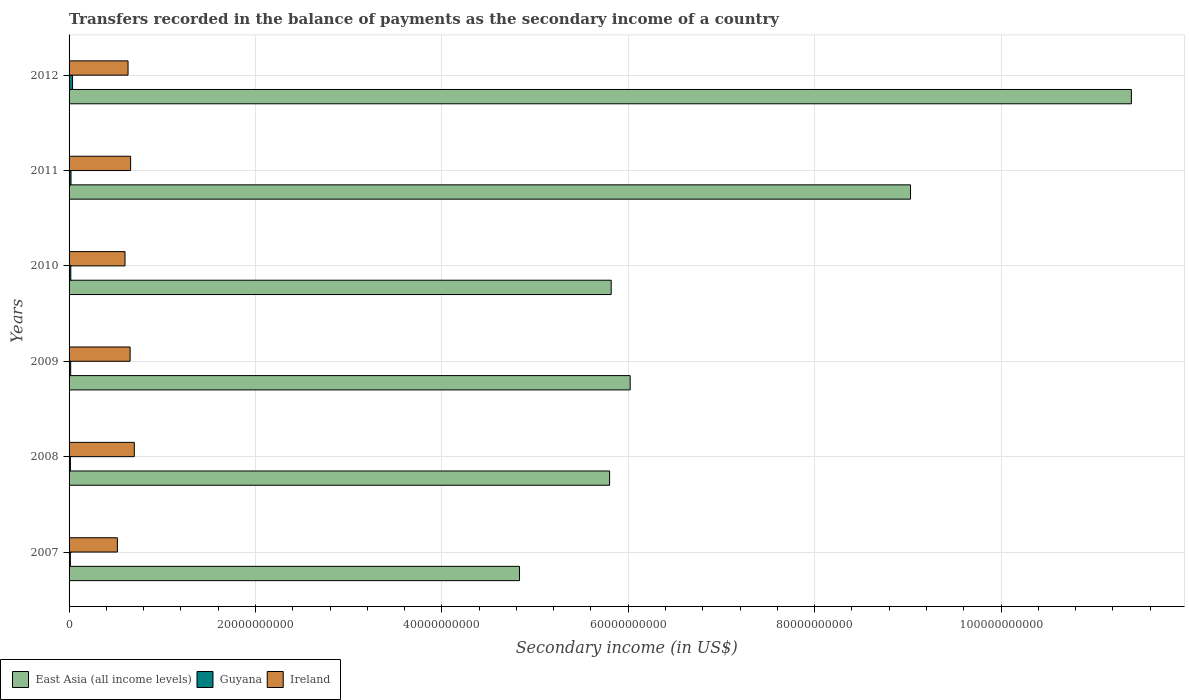Are the number of bars on each tick of the Y-axis equal?
Offer a terse response. Yes. How many bars are there on the 5th tick from the top?
Keep it short and to the point. 3. How many bars are there on the 1st tick from the bottom?
Provide a succinct answer. 3. What is the secondary income of in Ireland in 2010?
Give a very brief answer. 6.00e+09. Across all years, what is the maximum secondary income of in Ireland?
Make the answer very short. 7.00e+09. Across all years, what is the minimum secondary income of in Ireland?
Offer a terse response. 5.18e+09. What is the total secondary income of in East Asia (all income levels) in the graph?
Give a very brief answer. 4.29e+11. What is the difference between the secondary income of in East Asia (all income levels) in 2010 and that in 2011?
Your response must be concise. -3.21e+1. What is the difference between the secondary income of in Guyana in 2010 and the secondary income of in Ireland in 2012?
Keep it short and to the point. -6.14e+09. What is the average secondary income of in East Asia (all income levels) per year?
Offer a terse response. 7.15e+1. In the year 2007, what is the difference between the secondary income of in Ireland and secondary income of in East Asia (all income levels)?
Give a very brief answer. -4.31e+1. What is the ratio of the secondary income of in Ireland in 2007 to that in 2012?
Ensure brevity in your answer.  0.82. Is the difference between the secondary income of in Ireland in 2007 and 2012 greater than the difference between the secondary income of in East Asia (all income levels) in 2007 and 2012?
Keep it short and to the point. Yes. What is the difference between the highest and the second highest secondary income of in Ireland?
Provide a short and direct response. 3.96e+08. What is the difference between the highest and the lowest secondary income of in Ireland?
Make the answer very short. 1.82e+09. In how many years, is the secondary income of in Guyana greater than the average secondary income of in Guyana taken over all years?
Make the answer very short. 2. What does the 3rd bar from the top in 2007 represents?
Your answer should be very brief. East Asia (all income levels). What does the 3rd bar from the bottom in 2010 represents?
Ensure brevity in your answer.  Ireland. Is it the case that in every year, the sum of the secondary income of in Ireland and secondary income of in East Asia (all income levels) is greater than the secondary income of in Guyana?
Keep it short and to the point. Yes. How many bars are there?
Provide a succinct answer. 18. Are the values on the major ticks of X-axis written in scientific E-notation?
Provide a short and direct response. No. Does the graph contain any zero values?
Your response must be concise. No. Does the graph contain grids?
Your answer should be compact. Yes. Where does the legend appear in the graph?
Ensure brevity in your answer.  Bottom left. How are the legend labels stacked?
Provide a short and direct response. Horizontal. What is the title of the graph?
Offer a very short reply. Transfers recorded in the balance of payments as the secondary income of a country. What is the label or title of the X-axis?
Make the answer very short. Secondary income (in US$). What is the Secondary income (in US$) of East Asia (all income levels) in 2007?
Provide a short and direct response. 4.83e+1. What is the Secondary income (in US$) of Guyana in 2007?
Your answer should be compact. 1.37e+08. What is the Secondary income (in US$) of Ireland in 2007?
Provide a short and direct response. 5.18e+09. What is the Secondary income (in US$) in East Asia (all income levels) in 2008?
Make the answer very short. 5.80e+1. What is the Secondary income (in US$) in Guyana in 2008?
Your answer should be very brief. 1.41e+08. What is the Secondary income (in US$) in Ireland in 2008?
Give a very brief answer. 7.00e+09. What is the Secondary income (in US$) of East Asia (all income levels) in 2009?
Make the answer very short. 6.02e+1. What is the Secondary income (in US$) of Guyana in 2009?
Make the answer very short. 1.72e+08. What is the Secondary income (in US$) in Ireland in 2009?
Provide a short and direct response. 6.55e+09. What is the Secondary income (in US$) of East Asia (all income levels) in 2010?
Your response must be concise. 5.82e+1. What is the Secondary income (in US$) of Guyana in 2010?
Provide a succinct answer. 1.85e+08. What is the Secondary income (in US$) in Ireland in 2010?
Offer a very short reply. 6.00e+09. What is the Secondary income (in US$) in East Asia (all income levels) in 2011?
Make the answer very short. 9.03e+1. What is the Secondary income (in US$) in Guyana in 2011?
Ensure brevity in your answer.  2.08e+08. What is the Secondary income (in US$) of Ireland in 2011?
Keep it short and to the point. 6.61e+09. What is the Secondary income (in US$) of East Asia (all income levels) in 2012?
Provide a short and direct response. 1.14e+11. What is the Secondary income (in US$) in Guyana in 2012?
Ensure brevity in your answer.  3.71e+08. What is the Secondary income (in US$) of Ireland in 2012?
Make the answer very short. 6.33e+09. Across all years, what is the maximum Secondary income (in US$) of East Asia (all income levels)?
Keep it short and to the point. 1.14e+11. Across all years, what is the maximum Secondary income (in US$) of Guyana?
Your response must be concise. 3.71e+08. Across all years, what is the maximum Secondary income (in US$) in Ireland?
Ensure brevity in your answer.  7.00e+09. Across all years, what is the minimum Secondary income (in US$) in East Asia (all income levels)?
Give a very brief answer. 4.83e+1. Across all years, what is the minimum Secondary income (in US$) in Guyana?
Give a very brief answer. 1.37e+08. Across all years, what is the minimum Secondary income (in US$) of Ireland?
Give a very brief answer. 5.18e+09. What is the total Secondary income (in US$) in East Asia (all income levels) in the graph?
Make the answer very short. 4.29e+11. What is the total Secondary income (in US$) of Guyana in the graph?
Your answer should be compact. 1.21e+09. What is the total Secondary income (in US$) in Ireland in the graph?
Your answer should be very brief. 3.77e+1. What is the difference between the Secondary income (in US$) of East Asia (all income levels) in 2007 and that in 2008?
Keep it short and to the point. -9.67e+09. What is the difference between the Secondary income (in US$) in Guyana in 2007 and that in 2008?
Provide a succinct answer. -4.12e+06. What is the difference between the Secondary income (in US$) in Ireland in 2007 and that in 2008?
Offer a very short reply. -1.82e+09. What is the difference between the Secondary income (in US$) of East Asia (all income levels) in 2007 and that in 2009?
Provide a succinct answer. -1.19e+1. What is the difference between the Secondary income (in US$) of Guyana in 2007 and that in 2009?
Keep it short and to the point. -3.51e+07. What is the difference between the Secondary income (in US$) in Ireland in 2007 and that in 2009?
Your response must be concise. -1.37e+09. What is the difference between the Secondary income (in US$) of East Asia (all income levels) in 2007 and that in 2010?
Give a very brief answer. -9.84e+09. What is the difference between the Secondary income (in US$) of Guyana in 2007 and that in 2010?
Offer a very short reply. -4.78e+07. What is the difference between the Secondary income (in US$) of Ireland in 2007 and that in 2010?
Ensure brevity in your answer.  -8.19e+08. What is the difference between the Secondary income (in US$) in East Asia (all income levels) in 2007 and that in 2011?
Your answer should be very brief. -4.20e+1. What is the difference between the Secondary income (in US$) of Guyana in 2007 and that in 2011?
Your response must be concise. -7.14e+07. What is the difference between the Secondary income (in US$) in Ireland in 2007 and that in 2011?
Ensure brevity in your answer.  -1.42e+09. What is the difference between the Secondary income (in US$) of East Asia (all income levels) in 2007 and that in 2012?
Make the answer very short. -6.57e+1. What is the difference between the Secondary income (in US$) of Guyana in 2007 and that in 2012?
Provide a succinct answer. -2.34e+08. What is the difference between the Secondary income (in US$) of Ireland in 2007 and that in 2012?
Your answer should be very brief. -1.14e+09. What is the difference between the Secondary income (in US$) in East Asia (all income levels) in 2008 and that in 2009?
Offer a terse response. -2.21e+09. What is the difference between the Secondary income (in US$) in Guyana in 2008 and that in 2009?
Ensure brevity in your answer.  -3.10e+07. What is the difference between the Secondary income (in US$) in Ireland in 2008 and that in 2009?
Provide a succinct answer. 4.52e+08. What is the difference between the Secondary income (in US$) of East Asia (all income levels) in 2008 and that in 2010?
Offer a very short reply. -1.74e+08. What is the difference between the Secondary income (in US$) in Guyana in 2008 and that in 2010?
Ensure brevity in your answer.  -4.37e+07. What is the difference between the Secondary income (in US$) of Ireland in 2008 and that in 2010?
Give a very brief answer. 9.97e+08. What is the difference between the Secondary income (in US$) of East Asia (all income levels) in 2008 and that in 2011?
Keep it short and to the point. -3.23e+1. What is the difference between the Secondary income (in US$) in Guyana in 2008 and that in 2011?
Keep it short and to the point. -6.72e+07. What is the difference between the Secondary income (in US$) of Ireland in 2008 and that in 2011?
Give a very brief answer. 3.96e+08. What is the difference between the Secondary income (in US$) of East Asia (all income levels) in 2008 and that in 2012?
Provide a succinct answer. -5.60e+1. What is the difference between the Secondary income (in US$) in Guyana in 2008 and that in 2012?
Your answer should be compact. -2.30e+08. What is the difference between the Secondary income (in US$) in Ireland in 2008 and that in 2012?
Offer a terse response. 6.74e+08. What is the difference between the Secondary income (in US$) of East Asia (all income levels) in 2009 and that in 2010?
Offer a terse response. 2.03e+09. What is the difference between the Secondary income (in US$) of Guyana in 2009 and that in 2010?
Provide a short and direct response. -1.27e+07. What is the difference between the Secondary income (in US$) in Ireland in 2009 and that in 2010?
Your response must be concise. 5.46e+08. What is the difference between the Secondary income (in US$) in East Asia (all income levels) in 2009 and that in 2011?
Give a very brief answer. -3.01e+1. What is the difference between the Secondary income (in US$) of Guyana in 2009 and that in 2011?
Your answer should be very brief. -3.63e+07. What is the difference between the Secondary income (in US$) of Ireland in 2009 and that in 2011?
Your answer should be very brief. -5.56e+07. What is the difference between the Secondary income (in US$) of East Asia (all income levels) in 2009 and that in 2012?
Keep it short and to the point. -5.38e+1. What is the difference between the Secondary income (in US$) in Guyana in 2009 and that in 2012?
Your answer should be compact. -1.99e+08. What is the difference between the Secondary income (in US$) in Ireland in 2009 and that in 2012?
Your response must be concise. 2.22e+08. What is the difference between the Secondary income (in US$) in East Asia (all income levels) in 2010 and that in 2011?
Offer a very short reply. -3.21e+1. What is the difference between the Secondary income (in US$) in Guyana in 2010 and that in 2011?
Offer a terse response. -2.36e+07. What is the difference between the Secondary income (in US$) in Ireland in 2010 and that in 2011?
Give a very brief answer. -6.02e+08. What is the difference between the Secondary income (in US$) in East Asia (all income levels) in 2010 and that in 2012?
Your answer should be compact. -5.58e+1. What is the difference between the Secondary income (in US$) in Guyana in 2010 and that in 2012?
Ensure brevity in your answer.  -1.86e+08. What is the difference between the Secondary income (in US$) in Ireland in 2010 and that in 2012?
Ensure brevity in your answer.  -3.24e+08. What is the difference between the Secondary income (in US$) in East Asia (all income levels) in 2011 and that in 2012?
Make the answer very short. -2.37e+1. What is the difference between the Secondary income (in US$) of Guyana in 2011 and that in 2012?
Provide a succinct answer. -1.63e+08. What is the difference between the Secondary income (in US$) of Ireland in 2011 and that in 2012?
Your answer should be compact. 2.78e+08. What is the difference between the Secondary income (in US$) of East Asia (all income levels) in 2007 and the Secondary income (in US$) of Guyana in 2008?
Your answer should be compact. 4.82e+1. What is the difference between the Secondary income (in US$) in East Asia (all income levels) in 2007 and the Secondary income (in US$) in Ireland in 2008?
Your answer should be very brief. 4.13e+1. What is the difference between the Secondary income (in US$) of Guyana in 2007 and the Secondary income (in US$) of Ireland in 2008?
Make the answer very short. -6.86e+09. What is the difference between the Secondary income (in US$) in East Asia (all income levels) in 2007 and the Secondary income (in US$) in Guyana in 2009?
Provide a succinct answer. 4.82e+1. What is the difference between the Secondary income (in US$) in East Asia (all income levels) in 2007 and the Secondary income (in US$) in Ireland in 2009?
Your response must be concise. 4.18e+1. What is the difference between the Secondary income (in US$) in Guyana in 2007 and the Secondary income (in US$) in Ireland in 2009?
Keep it short and to the point. -6.41e+09. What is the difference between the Secondary income (in US$) in East Asia (all income levels) in 2007 and the Secondary income (in US$) in Guyana in 2010?
Offer a terse response. 4.81e+1. What is the difference between the Secondary income (in US$) in East Asia (all income levels) in 2007 and the Secondary income (in US$) in Ireland in 2010?
Your response must be concise. 4.23e+1. What is the difference between the Secondary income (in US$) of Guyana in 2007 and the Secondary income (in US$) of Ireland in 2010?
Give a very brief answer. -5.87e+09. What is the difference between the Secondary income (in US$) of East Asia (all income levels) in 2007 and the Secondary income (in US$) of Guyana in 2011?
Offer a terse response. 4.81e+1. What is the difference between the Secondary income (in US$) in East Asia (all income levels) in 2007 and the Secondary income (in US$) in Ireland in 2011?
Keep it short and to the point. 4.17e+1. What is the difference between the Secondary income (in US$) of Guyana in 2007 and the Secondary income (in US$) of Ireland in 2011?
Make the answer very short. -6.47e+09. What is the difference between the Secondary income (in US$) in East Asia (all income levels) in 2007 and the Secondary income (in US$) in Guyana in 2012?
Your response must be concise. 4.80e+1. What is the difference between the Secondary income (in US$) in East Asia (all income levels) in 2007 and the Secondary income (in US$) in Ireland in 2012?
Make the answer very short. 4.20e+1. What is the difference between the Secondary income (in US$) of Guyana in 2007 and the Secondary income (in US$) of Ireland in 2012?
Ensure brevity in your answer.  -6.19e+09. What is the difference between the Secondary income (in US$) in East Asia (all income levels) in 2008 and the Secondary income (in US$) in Guyana in 2009?
Offer a very short reply. 5.78e+1. What is the difference between the Secondary income (in US$) of East Asia (all income levels) in 2008 and the Secondary income (in US$) of Ireland in 2009?
Keep it short and to the point. 5.14e+1. What is the difference between the Secondary income (in US$) of Guyana in 2008 and the Secondary income (in US$) of Ireland in 2009?
Provide a short and direct response. -6.41e+09. What is the difference between the Secondary income (in US$) of East Asia (all income levels) in 2008 and the Secondary income (in US$) of Guyana in 2010?
Provide a succinct answer. 5.78e+1. What is the difference between the Secondary income (in US$) of East Asia (all income levels) in 2008 and the Secondary income (in US$) of Ireland in 2010?
Provide a short and direct response. 5.20e+1. What is the difference between the Secondary income (in US$) of Guyana in 2008 and the Secondary income (in US$) of Ireland in 2010?
Provide a succinct answer. -5.86e+09. What is the difference between the Secondary income (in US$) of East Asia (all income levels) in 2008 and the Secondary income (in US$) of Guyana in 2011?
Your answer should be compact. 5.78e+1. What is the difference between the Secondary income (in US$) of East Asia (all income levels) in 2008 and the Secondary income (in US$) of Ireland in 2011?
Provide a short and direct response. 5.14e+1. What is the difference between the Secondary income (in US$) in Guyana in 2008 and the Secondary income (in US$) in Ireland in 2011?
Provide a short and direct response. -6.46e+09. What is the difference between the Secondary income (in US$) in East Asia (all income levels) in 2008 and the Secondary income (in US$) in Guyana in 2012?
Provide a short and direct response. 5.76e+1. What is the difference between the Secondary income (in US$) of East Asia (all income levels) in 2008 and the Secondary income (in US$) of Ireland in 2012?
Your answer should be very brief. 5.17e+1. What is the difference between the Secondary income (in US$) of Guyana in 2008 and the Secondary income (in US$) of Ireland in 2012?
Your answer should be very brief. -6.19e+09. What is the difference between the Secondary income (in US$) of East Asia (all income levels) in 2009 and the Secondary income (in US$) of Guyana in 2010?
Keep it short and to the point. 6.00e+1. What is the difference between the Secondary income (in US$) in East Asia (all income levels) in 2009 and the Secondary income (in US$) in Ireland in 2010?
Keep it short and to the point. 5.42e+1. What is the difference between the Secondary income (in US$) of Guyana in 2009 and the Secondary income (in US$) of Ireland in 2010?
Offer a terse response. -5.83e+09. What is the difference between the Secondary income (in US$) in East Asia (all income levels) in 2009 and the Secondary income (in US$) in Guyana in 2011?
Provide a succinct answer. 6.00e+1. What is the difference between the Secondary income (in US$) of East Asia (all income levels) in 2009 and the Secondary income (in US$) of Ireland in 2011?
Provide a short and direct response. 5.36e+1. What is the difference between the Secondary income (in US$) in Guyana in 2009 and the Secondary income (in US$) in Ireland in 2011?
Keep it short and to the point. -6.43e+09. What is the difference between the Secondary income (in US$) in East Asia (all income levels) in 2009 and the Secondary income (in US$) in Guyana in 2012?
Offer a very short reply. 5.98e+1. What is the difference between the Secondary income (in US$) of East Asia (all income levels) in 2009 and the Secondary income (in US$) of Ireland in 2012?
Your response must be concise. 5.39e+1. What is the difference between the Secondary income (in US$) in Guyana in 2009 and the Secondary income (in US$) in Ireland in 2012?
Make the answer very short. -6.16e+09. What is the difference between the Secondary income (in US$) in East Asia (all income levels) in 2010 and the Secondary income (in US$) in Guyana in 2011?
Provide a succinct answer. 5.80e+1. What is the difference between the Secondary income (in US$) of East Asia (all income levels) in 2010 and the Secondary income (in US$) of Ireland in 2011?
Ensure brevity in your answer.  5.16e+1. What is the difference between the Secondary income (in US$) in Guyana in 2010 and the Secondary income (in US$) in Ireland in 2011?
Make the answer very short. -6.42e+09. What is the difference between the Secondary income (in US$) in East Asia (all income levels) in 2010 and the Secondary income (in US$) in Guyana in 2012?
Provide a succinct answer. 5.78e+1. What is the difference between the Secondary income (in US$) of East Asia (all income levels) in 2010 and the Secondary income (in US$) of Ireland in 2012?
Offer a terse response. 5.18e+1. What is the difference between the Secondary income (in US$) of Guyana in 2010 and the Secondary income (in US$) of Ireland in 2012?
Give a very brief answer. -6.14e+09. What is the difference between the Secondary income (in US$) in East Asia (all income levels) in 2011 and the Secondary income (in US$) in Guyana in 2012?
Your response must be concise. 8.99e+1. What is the difference between the Secondary income (in US$) in East Asia (all income levels) in 2011 and the Secondary income (in US$) in Ireland in 2012?
Ensure brevity in your answer.  8.40e+1. What is the difference between the Secondary income (in US$) of Guyana in 2011 and the Secondary income (in US$) of Ireland in 2012?
Give a very brief answer. -6.12e+09. What is the average Secondary income (in US$) in East Asia (all income levels) per year?
Offer a terse response. 7.15e+1. What is the average Secondary income (in US$) in Guyana per year?
Offer a terse response. 2.02e+08. What is the average Secondary income (in US$) in Ireland per year?
Provide a short and direct response. 6.28e+09. In the year 2007, what is the difference between the Secondary income (in US$) of East Asia (all income levels) and Secondary income (in US$) of Guyana?
Provide a short and direct response. 4.82e+1. In the year 2007, what is the difference between the Secondary income (in US$) of East Asia (all income levels) and Secondary income (in US$) of Ireland?
Offer a very short reply. 4.31e+1. In the year 2007, what is the difference between the Secondary income (in US$) of Guyana and Secondary income (in US$) of Ireland?
Offer a terse response. -5.05e+09. In the year 2008, what is the difference between the Secondary income (in US$) of East Asia (all income levels) and Secondary income (in US$) of Guyana?
Provide a succinct answer. 5.79e+1. In the year 2008, what is the difference between the Secondary income (in US$) in East Asia (all income levels) and Secondary income (in US$) in Ireland?
Your response must be concise. 5.10e+1. In the year 2008, what is the difference between the Secondary income (in US$) in Guyana and Secondary income (in US$) in Ireland?
Offer a terse response. -6.86e+09. In the year 2009, what is the difference between the Secondary income (in US$) in East Asia (all income levels) and Secondary income (in US$) in Guyana?
Ensure brevity in your answer.  6.00e+1. In the year 2009, what is the difference between the Secondary income (in US$) of East Asia (all income levels) and Secondary income (in US$) of Ireland?
Your answer should be very brief. 5.37e+1. In the year 2009, what is the difference between the Secondary income (in US$) in Guyana and Secondary income (in US$) in Ireland?
Offer a terse response. -6.38e+09. In the year 2010, what is the difference between the Secondary income (in US$) in East Asia (all income levels) and Secondary income (in US$) in Guyana?
Your response must be concise. 5.80e+1. In the year 2010, what is the difference between the Secondary income (in US$) in East Asia (all income levels) and Secondary income (in US$) in Ireland?
Provide a succinct answer. 5.22e+1. In the year 2010, what is the difference between the Secondary income (in US$) in Guyana and Secondary income (in US$) in Ireland?
Your answer should be compact. -5.82e+09. In the year 2011, what is the difference between the Secondary income (in US$) in East Asia (all income levels) and Secondary income (in US$) in Guyana?
Offer a very short reply. 9.01e+1. In the year 2011, what is the difference between the Secondary income (in US$) of East Asia (all income levels) and Secondary income (in US$) of Ireland?
Provide a succinct answer. 8.37e+1. In the year 2011, what is the difference between the Secondary income (in US$) in Guyana and Secondary income (in US$) in Ireland?
Make the answer very short. -6.40e+09. In the year 2012, what is the difference between the Secondary income (in US$) of East Asia (all income levels) and Secondary income (in US$) of Guyana?
Your answer should be compact. 1.14e+11. In the year 2012, what is the difference between the Secondary income (in US$) in East Asia (all income levels) and Secondary income (in US$) in Ireland?
Your response must be concise. 1.08e+11. In the year 2012, what is the difference between the Secondary income (in US$) in Guyana and Secondary income (in US$) in Ireland?
Ensure brevity in your answer.  -5.96e+09. What is the ratio of the Secondary income (in US$) in East Asia (all income levels) in 2007 to that in 2008?
Your answer should be very brief. 0.83. What is the ratio of the Secondary income (in US$) in Guyana in 2007 to that in 2008?
Provide a succinct answer. 0.97. What is the ratio of the Secondary income (in US$) of Ireland in 2007 to that in 2008?
Your answer should be compact. 0.74. What is the ratio of the Secondary income (in US$) in East Asia (all income levels) in 2007 to that in 2009?
Your response must be concise. 0.8. What is the ratio of the Secondary income (in US$) in Guyana in 2007 to that in 2009?
Your response must be concise. 0.8. What is the ratio of the Secondary income (in US$) of Ireland in 2007 to that in 2009?
Give a very brief answer. 0.79. What is the ratio of the Secondary income (in US$) in East Asia (all income levels) in 2007 to that in 2010?
Your answer should be compact. 0.83. What is the ratio of the Secondary income (in US$) in Guyana in 2007 to that in 2010?
Provide a short and direct response. 0.74. What is the ratio of the Secondary income (in US$) of Ireland in 2007 to that in 2010?
Your answer should be compact. 0.86. What is the ratio of the Secondary income (in US$) in East Asia (all income levels) in 2007 to that in 2011?
Ensure brevity in your answer.  0.54. What is the ratio of the Secondary income (in US$) in Guyana in 2007 to that in 2011?
Provide a succinct answer. 0.66. What is the ratio of the Secondary income (in US$) in Ireland in 2007 to that in 2011?
Give a very brief answer. 0.78. What is the ratio of the Secondary income (in US$) in East Asia (all income levels) in 2007 to that in 2012?
Offer a very short reply. 0.42. What is the ratio of the Secondary income (in US$) in Guyana in 2007 to that in 2012?
Offer a very short reply. 0.37. What is the ratio of the Secondary income (in US$) of Ireland in 2007 to that in 2012?
Your answer should be compact. 0.82. What is the ratio of the Secondary income (in US$) of East Asia (all income levels) in 2008 to that in 2009?
Ensure brevity in your answer.  0.96. What is the ratio of the Secondary income (in US$) of Guyana in 2008 to that in 2009?
Provide a succinct answer. 0.82. What is the ratio of the Secondary income (in US$) of Ireland in 2008 to that in 2009?
Offer a terse response. 1.07. What is the ratio of the Secondary income (in US$) in East Asia (all income levels) in 2008 to that in 2010?
Offer a terse response. 1. What is the ratio of the Secondary income (in US$) in Guyana in 2008 to that in 2010?
Give a very brief answer. 0.76. What is the ratio of the Secondary income (in US$) in Ireland in 2008 to that in 2010?
Offer a terse response. 1.17. What is the ratio of the Secondary income (in US$) of East Asia (all income levels) in 2008 to that in 2011?
Ensure brevity in your answer.  0.64. What is the ratio of the Secondary income (in US$) in Guyana in 2008 to that in 2011?
Your answer should be very brief. 0.68. What is the ratio of the Secondary income (in US$) in Ireland in 2008 to that in 2011?
Your response must be concise. 1.06. What is the ratio of the Secondary income (in US$) of East Asia (all income levels) in 2008 to that in 2012?
Your answer should be very brief. 0.51. What is the ratio of the Secondary income (in US$) of Guyana in 2008 to that in 2012?
Make the answer very short. 0.38. What is the ratio of the Secondary income (in US$) of Ireland in 2008 to that in 2012?
Keep it short and to the point. 1.11. What is the ratio of the Secondary income (in US$) in East Asia (all income levels) in 2009 to that in 2010?
Offer a very short reply. 1.03. What is the ratio of the Secondary income (in US$) in Guyana in 2009 to that in 2010?
Provide a short and direct response. 0.93. What is the ratio of the Secondary income (in US$) of Ireland in 2009 to that in 2010?
Provide a short and direct response. 1.09. What is the ratio of the Secondary income (in US$) in East Asia (all income levels) in 2009 to that in 2011?
Your answer should be compact. 0.67. What is the ratio of the Secondary income (in US$) in Guyana in 2009 to that in 2011?
Ensure brevity in your answer.  0.83. What is the ratio of the Secondary income (in US$) of East Asia (all income levels) in 2009 to that in 2012?
Make the answer very short. 0.53. What is the ratio of the Secondary income (in US$) of Guyana in 2009 to that in 2012?
Your answer should be very brief. 0.46. What is the ratio of the Secondary income (in US$) of Ireland in 2009 to that in 2012?
Provide a short and direct response. 1.04. What is the ratio of the Secondary income (in US$) of East Asia (all income levels) in 2010 to that in 2011?
Your answer should be very brief. 0.64. What is the ratio of the Secondary income (in US$) in Guyana in 2010 to that in 2011?
Keep it short and to the point. 0.89. What is the ratio of the Secondary income (in US$) of Ireland in 2010 to that in 2011?
Your answer should be compact. 0.91. What is the ratio of the Secondary income (in US$) in East Asia (all income levels) in 2010 to that in 2012?
Keep it short and to the point. 0.51. What is the ratio of the Secondary income (in US$) of Guyana in 2010 to that in 2012?
Ensure brevity in your answer.  0.5. What is the ratio of the Secondary income (in US$) in Ireland in 2010 to that in 2012?
Your response must be concise. 0.95. What is the ratio of the Secondary income (in US$) of East Asia (all income levels) in 2011 to that in 2012?
Your answer should be very brief. 0.79. What is the ratio of the Secondary income (in US$) in Guyana in 2011 to that in 2012?
Ensure brevity in your answer.  0.56. What is the ratio of the Secondary income (in US$) of Ireland in 2011 to that in 2012?
Offer a terse response. 1.04. What is the difference between the highest and the second highest Secondary income (in US$) in East Asia (all income levels)?
Ensure brevity in your answer.  2.37e+1. What is the difference between the highest and the second highest Secondary income (in US$) in Guyana?
Your response must be concise. 1.63e+08. What is the difference between the highest and the second highest Secondary income (in US$) in Ireland?
Make the answer very short. 3.96e+08. What is the difference between the highest and the lowest Secondary income (in US$) of East Asia (all income levels)?
Ensure brevity in your answer.  6.57e+1. What is the difference between the highest and the lowest Secondary income (in US$) of Guyana?
Provide a short and direct response. 2.34e+08. What is the difference between the highest and the lowest Secondary income (in US$) in Ireland?
Ensure brevity in your answer.  1.82e+09. 